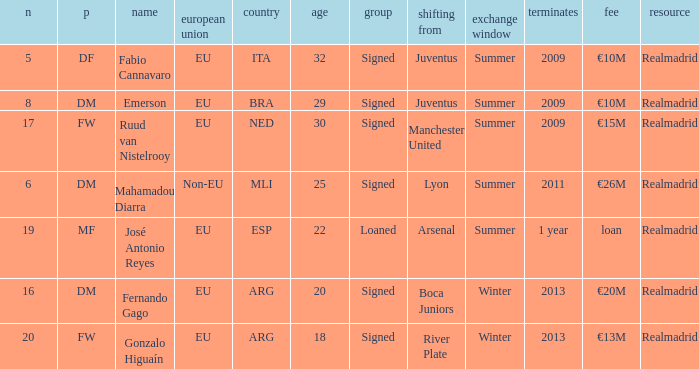What is the category of the player with a €20m transfer fee? Signed. 